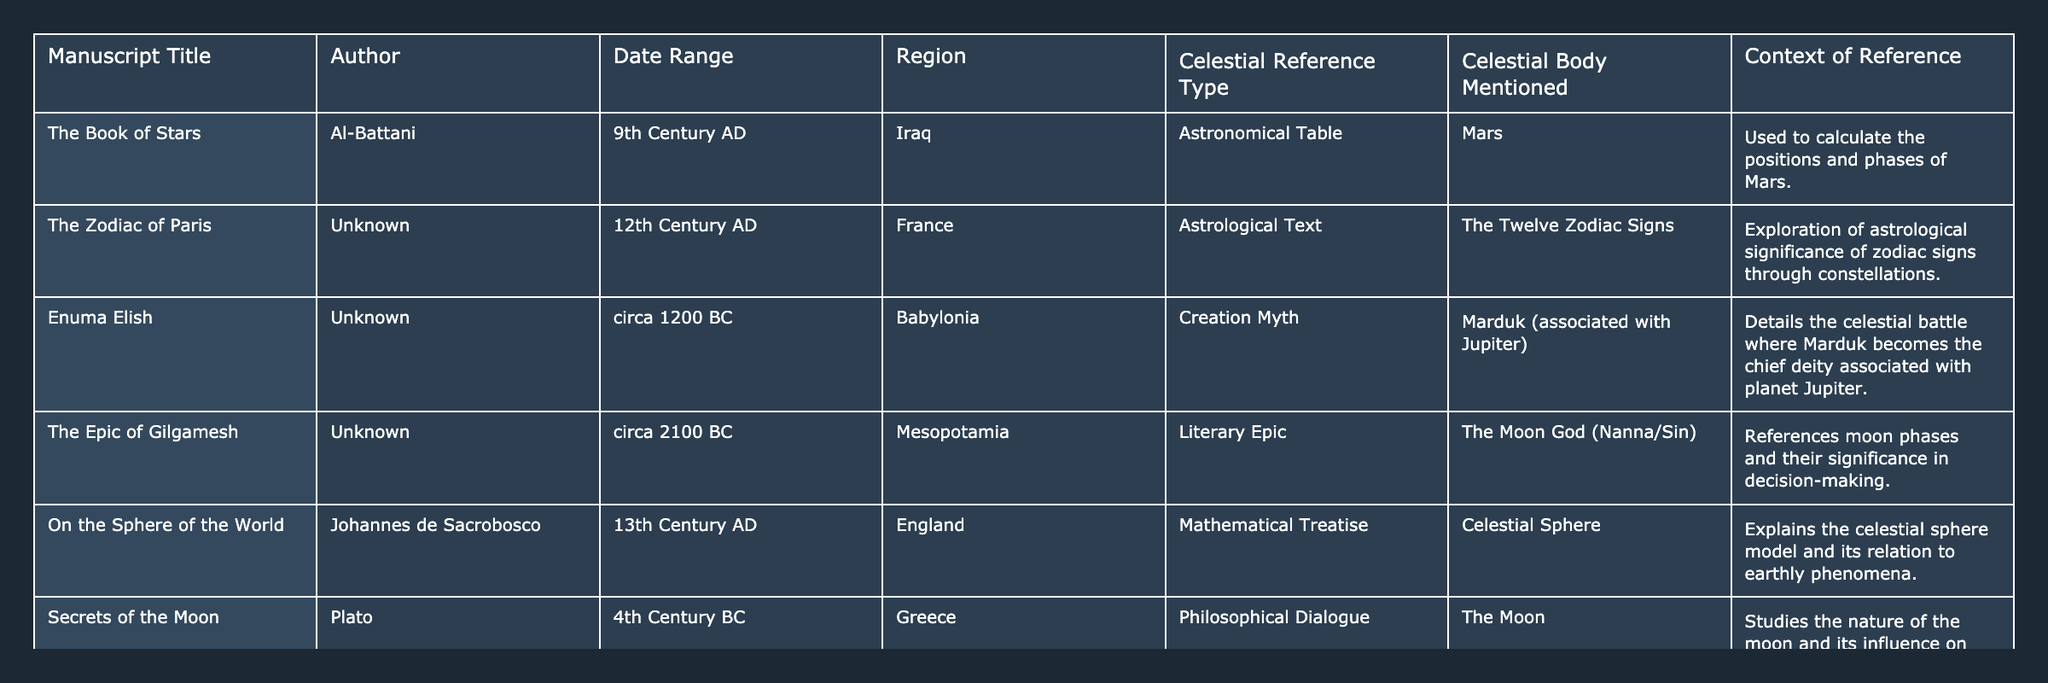What celestial body is mentioned in "The Epic of Gilgamesh"? In the table, the reference under the "Celestial Body Mentioned" column for "The Epic of Gilgamesh" is "The Moon God (Nanna/Sin)."
Answer: The Moon God (Nanna/Sin) Which manuscript from the 9th century discusses Mars? The table indicates that "The Book of Stars" by Al-Battani, created in the 9th century AD, references Mars.
Answer: "The Book of Stars" Is there an astrological text mentioned in the 12th century? Yes, the table lists "The Zodiac of Paris," an astrological text from the 12th century.
Answer: Yes How many celestial reference types are listed in the table? The table shows five unique celestial reference types: Astronomical Table, Astrological Text, Creation Myth, Literary Epic, and Mathematical Treatise.
Answer: Five Which region has manuscripts that reference the Moon? Both "The Epic of Gilgamesh" and "Secrets of the Moon" reference the Moon, and the regions are Mesopotamia and Greece, respectively.
Answer: Mesopotamia and Greece What is the significance of Marduk in the "Enuma Elish"? Marduk is associated with Jupiter and is described in the context of a celestial battle where he becomes the chief deity.
Answer: Chief deity associated with Jupiter Which author wrote about the celestial sphere? "On the Sphere of the World" was authored by Johannes de Sacrobosco, as indicated in the table.
Answer: Johannes de Sacrobosco Can we count how many manuscripts reference the Moon? In the table, two manuscripts reference the Moon: "The Epic of Gilgamesh" and "Secrets of the Moon." Therefore, the count is two.
Answer: Two What is the context of celestial references in "The Zodiac of Paris"? The table states that "The Zodiac of Paris" explores the astrological significance of zodiac signs through constellations.
Answer: Astrological significance of zodiac signs Which ancient manuscript includes a philosophical dialogue about celestial bodies? "Secrets of the Moon" by Plato is noted in the table as a philosophical dialogue concerning the Moon.
Answer: "Secrets of the Moon" 